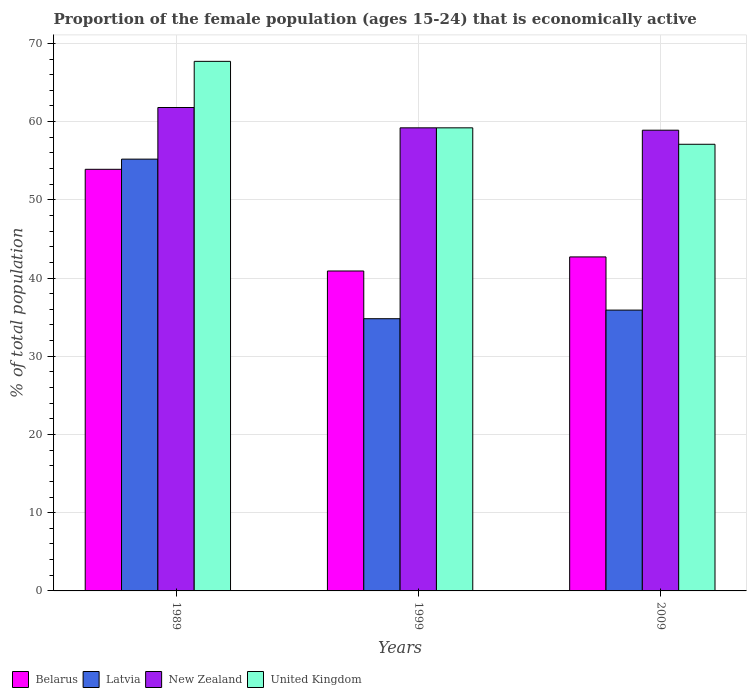How many different coloured bars are there?
Give a very brief answer. 4. How many groups of bars are there?
Offer a very short reply. 3. Are the number of bars per tick equal to the number of legend labels?
Make the answer very short. Yes. How many bars are there on the 3rd tick from the left?
Provide a short and direct response. 4. How many bars are there on the 1st tick from the right?
Offer a very short reply. 4. In how many cases, is the number of bars for a given year not equal to the number of legend labels?
Ensure brevity in your answer.  0. What is the proportion of the female population that is economically active in New Zealand in 2009?
Keep it short and to the point. 58.9. Across all years, what is the maximum proportion of the female population that is economically active in United Kingdom?
Offer a terse response. 67.7. Across all years, what is the minimum proportion of the female population that is economically active in New Zealand?
Offer a very short reply. 58.9. What is the total proportion of the female population that is economically active in New Zealand in the graph?
Make the answer very short. 179.9. What is the difference between the proportion of the female population that is economically active in Belarus in 1989 and that in 2009?
Your response must be concise. 11.2. What is the difference between the proportion of the female population that is economically active in United Kingdom in 1989 and the proportion of the female population that is economically active in Belarus in 1999?
Give a very brief answer. 26.8. What is the average proportion of the female population that is economically active in United Kingdom per year?
Your response must be concise. 61.33. In the year 1989, what is the difference between the proportion of the female population that is economically active in Belarus and proportion of the female population that is economically active in New Zealand?
Make the answer very short. -7.9. What is the ratio of the proportion of the female population that is economically active in New Zealand in 1989 to that in 1999?
Make the answer very short. 1.04. What is the difference between the highest and the second highest proportion of the female population that is economically active in New Zealand?
Provide a succinct answer. 2.6. What is the difference between the highest and the lowest proportion of the female population that is economically active in New Zealand?
Keep it short and to the point. 2.9. Is the sum of the proportion of the female population that is economically active in Belarus in 1999 and 2009 greater than the maximum proportion of the female population that is economically active in New Zealand across all years?
Your answer should be compact. Yes. What does the 2nd bar from the left in 2009 represents?
Give a very brief answer. Latvia. What does the 2nd bar from the right in 1999 represents?
Ensure brevity in your answer.  New Zealand. Is it the case that in every year, the sum of the proportion of the female population that is economically active in United Kingdom and proportion of the female population that is economically active in Belarus is greater than the proportion of the female population that is economically active in Latvia?
Provide a short and direct response. Yes. How many bars are there?
Give a very brief answer. 12. What is the difference between two consecutive major ticks on the Y-axis?
Offer a very short reply. 10. Are the values on the major ticks of Y-axis written in scientific E-notation?
Offer a very short reply. No. Does the graph contain grids?
Give a very brief answer. Yes. Where does the legend appear in the graph?
Your answer should be very brief. Bottom left. How many legend labels are there?
Your response must be concise. 4. How are the legend labels stacked?
Your answer should be very brief. Horizontal. What is the title of the graph?
Offer a very short reply. Proportion of the female population (ages 15-24) that is economically active. Does "Yemen, Rep." appear as one of the legend labels in the graph?
Keep it short and to the point. No. What is the label or title of the X-axis?
Make the answer very short. Years. What is the label or title of the Y-axis?
Your response must be concise. % of total population. What is the % of total population in Belarus in 1989?
Provide a succinct answer. 53.9. What is the % of total population in Latvia in 1989?
Your answer should be very brief. 55.2. What is the % of total population in New Zealand in 1989?
Your response must be concise. 61.8. What is the % of total population of United Kingdom in 1989?
Make the answer very short. 67.7. What is the % of total population of Belarus in 1999?
Offer a terse response. 40.9. What is the % of total population in Latvia in 1999?
Offer a terse response. 34.8. What is the % of total population in New Zealand in 1999?
Your answer should be compact. 59.2. What is the % of total population of United Kingdom in 1999?
Offer a terse response. 59.2. What is the % of total population of Belarus in 2009?
Your answer should be compact. 42.7. What is the % of total population of Latvia in 2009?
Ensure brevity in your answer.  35.9. What is the % of total population in New Zealand in 2009?
Make the answer very short. 58.9. What is the % of total population of United Kingdom in 2009?
Keep it short and to the point. 57.1. Across all years, what is the maximum % of total population in Belarus?
Keep it short and to the point. 53.9. Across all years, what is the maximum % of total population in Latvia?
Your answer should be compact. 55.2. Across all years, what is the maximum % of total population of New Zealand?
Your answer should be very brief. 61.8. Across all years, what is the maximum % of total population in United Kingdom?
Make the answer very short. 67.7. Across all years, what is the minimum % of total population in Belarus?
Provide a succinct answer. 40.9. Across all years, what is the minimum % of total population in Latvia?
Your answer should be compact. 34.8. Across all years, what is the minimum % of total population in New Zealand?
Offer a very short reply. 58.9. Across all years, what is the minimum % of total population of United Kingdom?
Ensure brevity in your answer.  57.1. What is the total % of total population of Belarus in the graph?
Your response must be concise. 137.5. What is the total % of total population of Latvia in the graph?
Provide a succinct answer. 125.9. What is the total % of total population in New Zealand in the graph?
Your response must be concise. 179.9. What is the total % of total population of United Kingdom in the graph?
Provide a short and direct response. 184. What is the difference between the % of total population in Latvia in 1989 and that in 1999?
Your response must be concise. 20.4. What is the difference between the % of total population of Belarus in 1989 and that in 2009?
Give a very brief answer. 11.2. What is the difference between the % of total population in Latvia in 1989 and that in 2009?
Your answer should be very brief. 19.3. What is the difference between the % of total population in New Zealand in 1989 and that in 2009?
Offer a terse response. 2.9. What is the difference between the % of total population in Belarus in 1999 and that in 2009?
Your answer should be very brief. -1.8. What is the difference between the % of total population in New Zealand in 1999 and that in 2009?
Your response must be concise. 0.3. What is the difference between the % of total population of United Kingdom in 1999 and that in 2009?
Your response must be concise. 2.1. What is the difference between the % of total population in Belarus in 1989 and the % of total population in New Zealand in 1999?
Offer a very short reply. -5.3. What is the difference between the % of total population in Latvia in 1989 and the % of total population in United Kingdom in 1999?
Provide a short and direct response. -4. What is the difference between the % of total population in New Zealand in 1989 and the % of total population in United Kingdom in 1999?
Keep it short and to the point. 2.6. What is the difference between the % of total population in Belarus in 1989 and the % of total population in Latvia in 2009?
Your answer should be very brief. 18. What is the difference between the % of total population of Belarus in 1989 and the % of total population of New Zealand in 2009?
Your answer should be compact. -5. What is the difference between the % of total population of Latvia in 1989 and the % of total population of New Zealand in 2009?
Provide a short and direct response. -3.7. What is the difference between the % of total population in Belarus in 1999 and the % of total population in United Kingdom in 2009?
Keep it short and to the point. -16.2. What is the difference between the % of total population in Latvia in 1999 and the % of total population in New Zealand in 2009?
Your answer should be very brief. -24.1. What is the difference between the % of total population of Latvia in 1999 and the % of total population of United Kingdom in 2009?
Your response must be concise. -22.3. What is the average % of total population of Belarus per year?
Provide a short and direct response. 45.83. What is the average % of total population in Latvia per year?
Your response must be concise. 41.97. What is the average % of total population in New Zealand per year?
Provide a succinct answer. 59.97. What is the average % of total population in United Kingdom per year?
Provide a succinct answer. 61.33. In the year 1989, what is the difference between the % of total population of Belarus and % of total population of Latvia?
Give a very brief answer. -1.3. In the year 1989, what is the difference between the % of total population of Belarus and % of total population of United Kingdom?
Ensure brevity in your answer.  -13.8. In the year 1989, what is the difference between the % of total population of Latvia and % of total population of New Zealand?
Offer a terse response. -6.6. In the year 1989, what is the difference between the % of total population in Latvia and % of total population in United Kingdom?
Make the answer very short. -12.5. In the year 1989, what is the difference between the % of total population of New Zealand and % of total population of United Kingdom?
Your answer should be very brief. -5.9. In the year 1999, what is the difference between the % of total population of Belarus and % of total population of Latvia?
Offer a very short reply. 6.1. In the year 1999, what is the difference between the % of total population of Belarus and % of total population of New Zealand?
Keep it short and to the point. -18.3. In the year 1999, what is the difference between the % of total population of Belarus and % of total population of United Kingdom?
Make the answer very short. -18.3. In the year 1999, what is the difference between the % of total population in Latvia and % of total population in New Zealand?
Your response must be concise. -24.4. In the year 1999, what is the difference between the % of total population of Latvia and % of total population of United Kingdom?
Your answer should be compact. -24.4. In the year 1999, what is the difference between the % of total population of New Zealand and % of total population of United Kingdom?
Offer a terse response. 0. In the year 2009, what is the difference between the % of total population in Belarus and % of total population in Latvia?
Ensure brevity in your answer.  6.8. In the year 2009, what is the difference between the % of total population of Belarus and % of total population of New Zealand?
Provide a succinct answer. -16.2. In the year 2009, what is the difference between the % of total population of Belarus and % of total population of United Kingdom?
Keep it short and to the point. -14.4. In the year 2009, what is the difference between the % of total population of Latvia and % of total population of New Zealand?
Offer a terse response. -23. In the year 2009, what is the difference between the % of total population of Latvia and % of total population of United Kingdom?
Offer a very short reply. -21.2. In the year 2009, what is the difference between the % of total population of New Zealand and % of total population of United Kingdom?
Provide a succinct answer. 1.8. What is the ratio of the % of total population of Belarus in 1989 to that in 1999?
Offer a very short reply. 1.32. What is the ratio of the % of total population of Latvia in 1989 to that in 1999?
Make the answer very short. 1.59. What is the ratio of the % of total population of New Zealand in 1989 to that in 1999?
Provide a short and direct response. 1.04. What is the ratio of the % of total population of United Kingdom in 1989 to that in 1999?
Your answer should be very brief. 1.14. What is the ratio of the % of total population in Belarus in 1989 to that in 2009?
Make the answer very short. 1.26. What is the ratio of the % of total population in Latvia in 1989 to that in 2009?
Provide a short and direct response. 1.54. What is the ratio of the % of total population of New Zealand in 1989 to that in 2009?
Ensure brevity in your answer.  1.05. What is the ratio of the % of total population in United Kingdom in 1989 to that in 2009?
Make the answer very short. 1.19. What is the ratio of the % of total population in Belarus in 1999 to that in 2009?
Provide a succinct answer. 0.96. What is the ratio of the % of total population in Latvia in 1999 to that in 2009?
Make the answer very short. 0.97. What is the ratio of the % of total population of New Zealand in 1999 to that in 2009?
Make the answer very short. 1.01. What is the ratio of the % of total population of United Kingdom in 1999 to that in 2009?
Your response must be concise. 1.04. What is the difference between the highest and the second highest % of total population of Belarus?
Provide a short and direct response. 11.2. What is the difference between the highest and the second highest % of total population of Latvia?
Provide a short and direct response. 19.3. What is the difference between the highest and the second highest % of total population of New Zealand?
Offer a terse response. 2.6. What is the difference between the highest and the second highest % of total population of United Kingdom?
Give a very brief answer. 8.5. What is the difference between the highest and the lowest % of total population of Belarus?
Your answer should be very brief. 13. What is the difference between the highest and the lowest % of total population of Latvia?
Keep it short and to the point. 20.4. What is the difference between the highest and the lowest % of total population in United Kingdom?
Offer a very short reply. 10.6. 